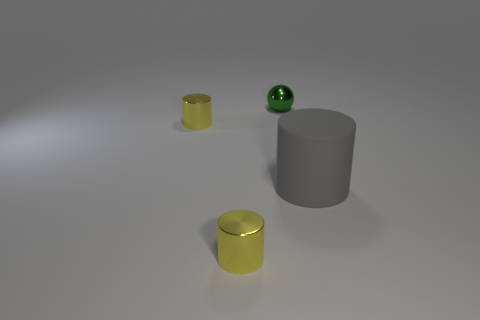Are there any other things that have the same material as the big gray cylinder?
Your answer should be compact. No. What is the shape of the tiny object that is behind the big cylinder and on the left side of the small green metal object?
Provide a succinct answer. Cylinder. Does the object that is in front of the big gray matte cylinder have the same size as the cylinder to the right of the green thing?
Give a very brief answer. No. Is there any other thing that is the same shape as the green metallic object?
Ensure brevity in your answer.  No. There is a cylinder that is left of the metallic cylinder to the right of the small yellow thing behind the big gray object; what color is it?
Give a very brief answer. Yellow. Is the number of tiny yellow things that are on the right side of the shiny ball less than the number of small objects that are behind the large gray matte cylinder?
Your answer should be compact. Yes. Does the gray thing have the same shape as the green thing?
Your answer should be compact. No. What number of yellow shiny things have the same size as the gray rubber object?
Provide a succinct answer. 0. Is the number of big gray rubber objects in front of the big matte cylinder less than the number of shiny cylinders?
Offer a terse response. Yes. There is a green thing left of the cylinder that is to the right of the small green shiny object; how big is it?
Your response must be concise. Small. 